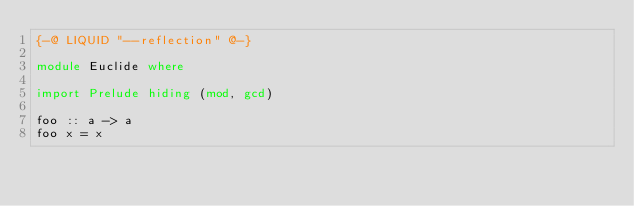Convert code to text. <code><loc_0><loc_0><loc_500><loc_500><_Haskell_>{-@ LIQUID "--reflection" @-} 

module Euclide where

import Prelude hiding (mod, gcd)

foo :: a -> a 
foo x = x 
</code> 